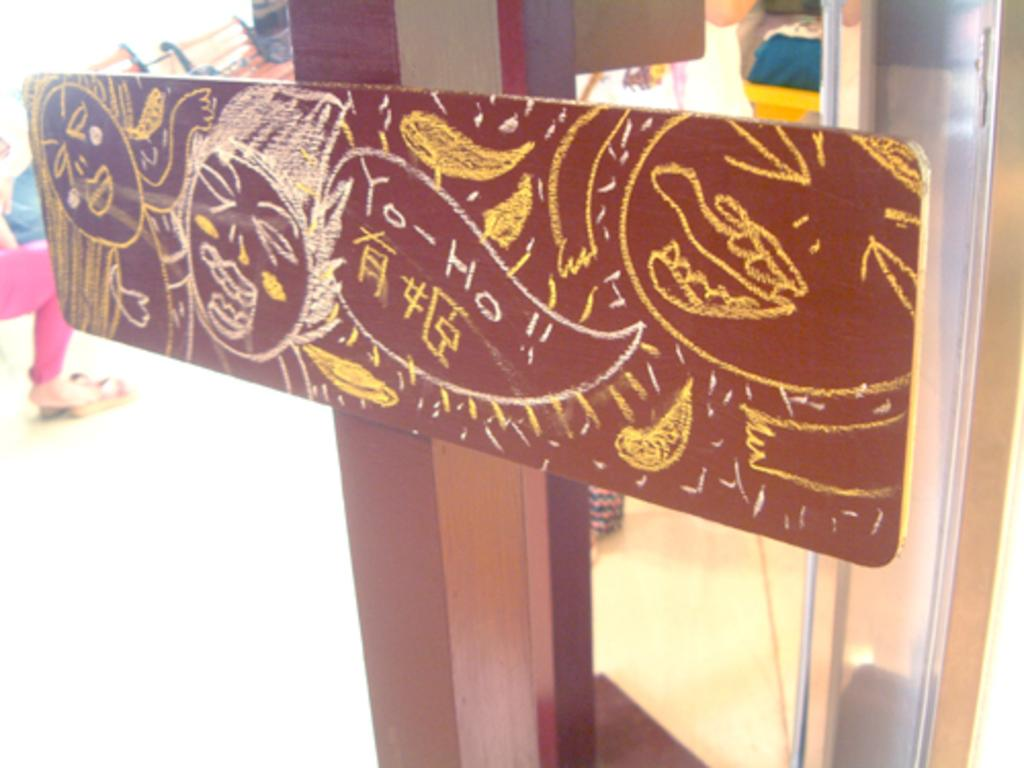What is attached to the pole in the image? There is a board attached to a pole in the image. What can be seen on the board? There are drawings on the board. What is the woman doing in the image? The woman is sitting on the left side of the image. What is the person on the right side of the image doing? There is a person standing on the right side of the image. What type of grass is growing around the pole in the image? There is no grass visible in the image; it only shows a board attached to a pole with drawings on it, a woman sitting on the left side, and a person standing on the right side. Is there a volcano erupting in the background of the image? There is no volcano present in the image. 